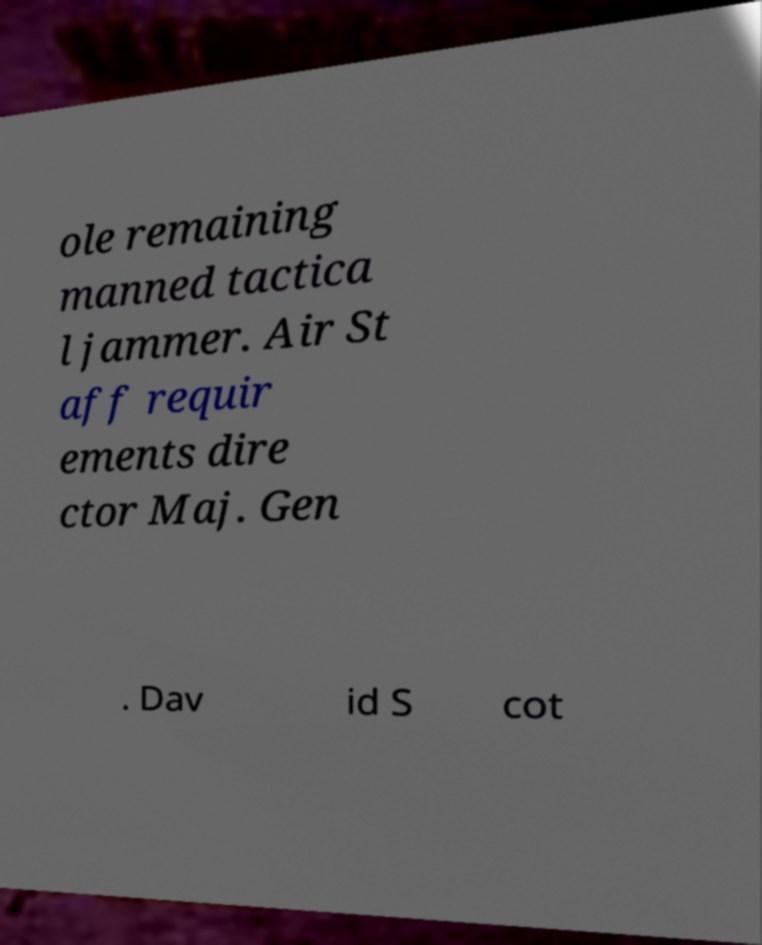Can you accurately transcribe the text from the provided image for me? ole remaining manned tactica l jammer. Air St aff requir ements dire ctor Maj. Gen . Dav id S cot 